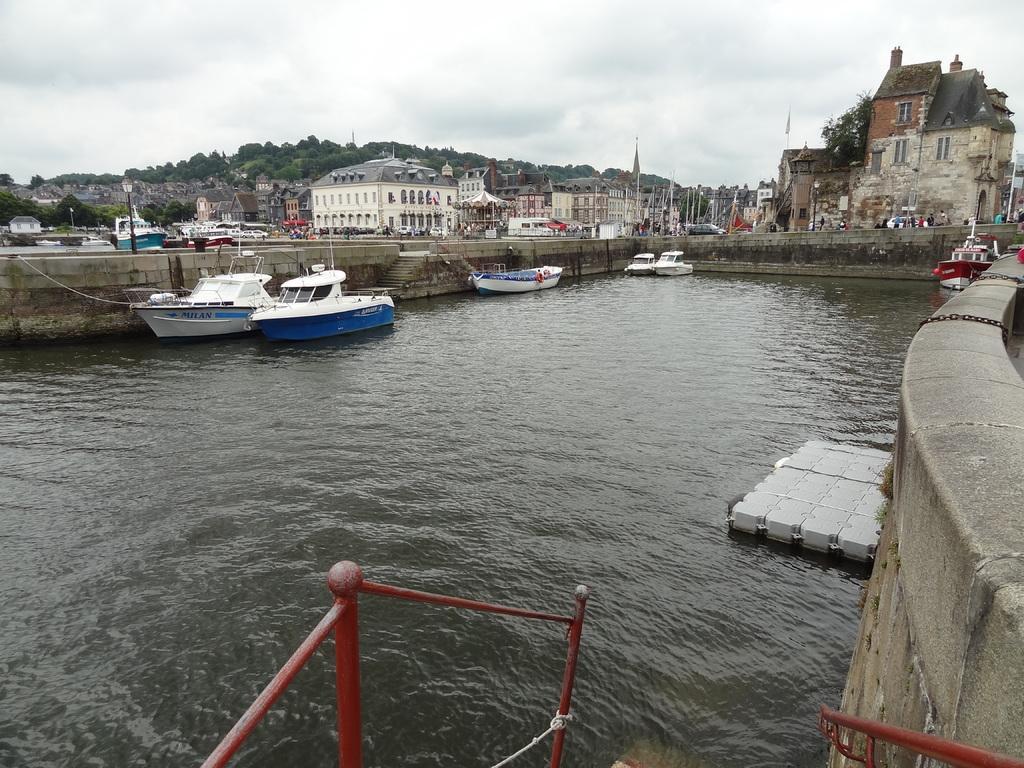Please provide a concise description of this image. This is an outside view. Here I can see a river and there are few boats on the water. In the background there are many buildings and trees. At the top, I can see the sky and clouds. On the right side there is a wall. At the bottom, I can see the railing. 